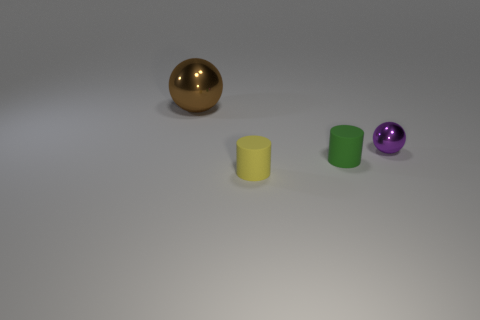What shape is the object that is behind the sphere right of the sphere to the left of the small shiny sphere?
Keep it short and to the point. Sphere. What number of other things are the same shape as the small purple object?
Ensure brevity in your answer.  1. What number of rubber things are either brown spheres or purple blocks?
Offer a terse response. 0. There is a small cylinder behind the tiny yellow matte cylinder in front of the small green matte object; what is its material?
Your answer should be very brief. Rubber. Are there more brown balls that are in front of the yellow rubber cylinder than cylinders?
Make the answer very short. No. Are there any blocks made of the same material as the green cylinder?
Your answer should be compact. No. There is a shiny object that is on the right side of the tiny yellow rubber object; does it have the same shape as the tiny green object?
Keep it short and to the point. No. What number of tiny metal objects are left of the sphere behind the metal object that is right of the big shiny sphere?
Provide a short and direct response. 0. Is the number of large brown shiny things that are to the right of the yellow rubber thing less than the number of tiny green cylinders behind the tiny purple metallic sphere?
Your answer should be very brief. No. What color is the other thing that is the same shape as the brown shiny thing?
Your answer should be compact. Purple. 